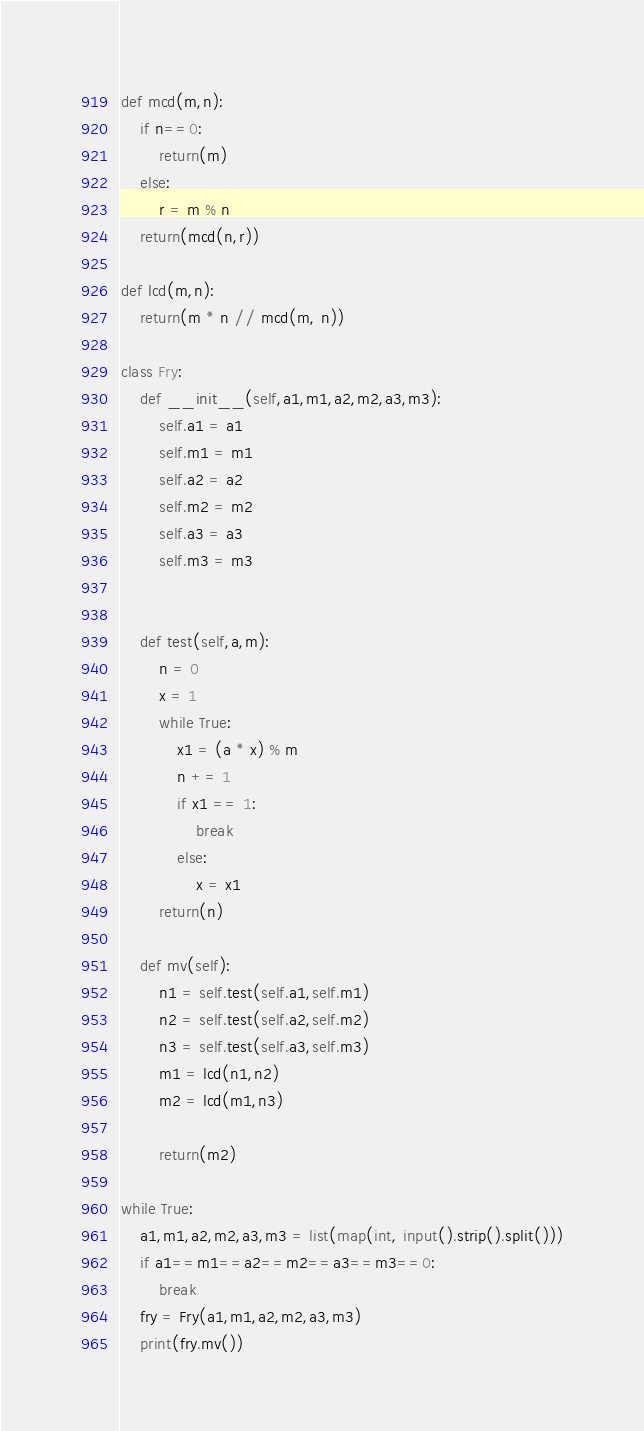<code> <loc_0><loc_0><loc_500><loc_500><_Python_>def mcd(m,n):
    if n==0:
        return(m)
    else:
        r = m % n
    return(mcd(n,r))

def lcd(m,n):
    return(m * n // mcd(m, n))

class Fry:
    def __init__(self,a1,m1,a2,m2,a3,m3):
        self.a1 = a1
        self.m1 = m1
        self.a2 = a2
        self.m2 = m2
        self.a3 = a3
        self.m3 = m3


    def test(self,a,m):
        n = 0
        x = 1
        while True:
            x1 = (a * x) % m
            n += 1
            if x1 == 1:
                break
            else:
                x = x1
        return(n)

    def mv(self):
        n1 = self.test(self.a1,self.m1)
        n2 = self.test(self.a2,self.m2)
        n3 = self.test(self.a3,self.m3)
        m1 = lcd(n1,n2)
        m2 = lcd(m1,n3)

        return(m2)

while True:
    a1,m1,a2,m2,a3,m3 = list(map(int, input().strip().split()))
    if a1==m1==a2==m2==a3==m3==0:
        break
    fry = Fry(a1,m1,a2,m2,a3,m3)
    print(fry.mv())</code> 